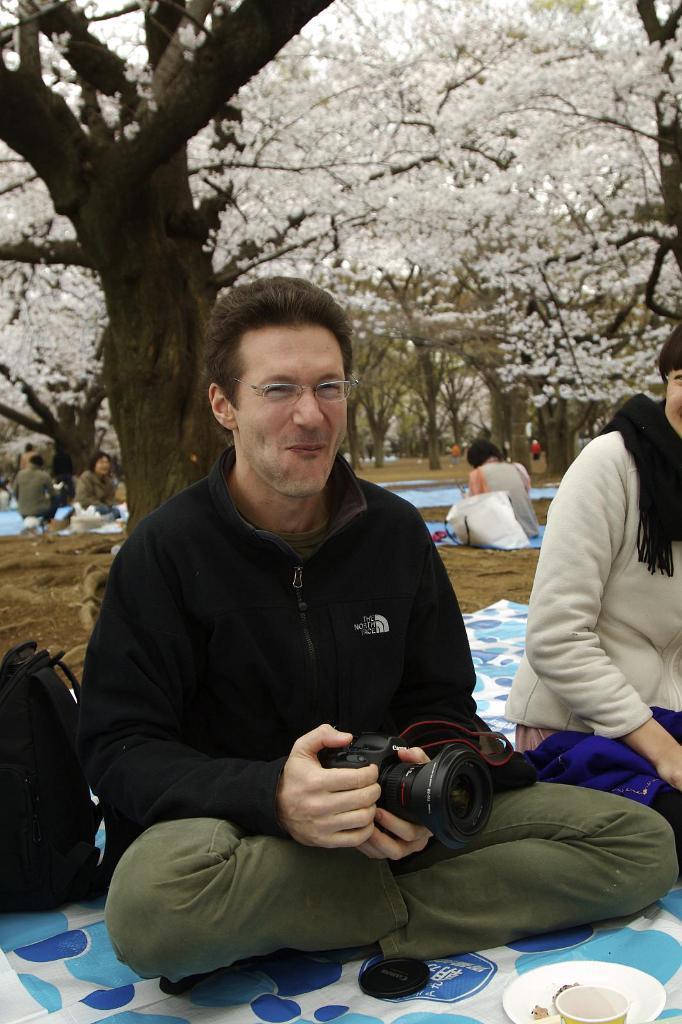Please provide a concise description of this image. In the image we can see few persons were sitting on the floor. And in the center we can see man holding camera. And back we can see trees,grass. 